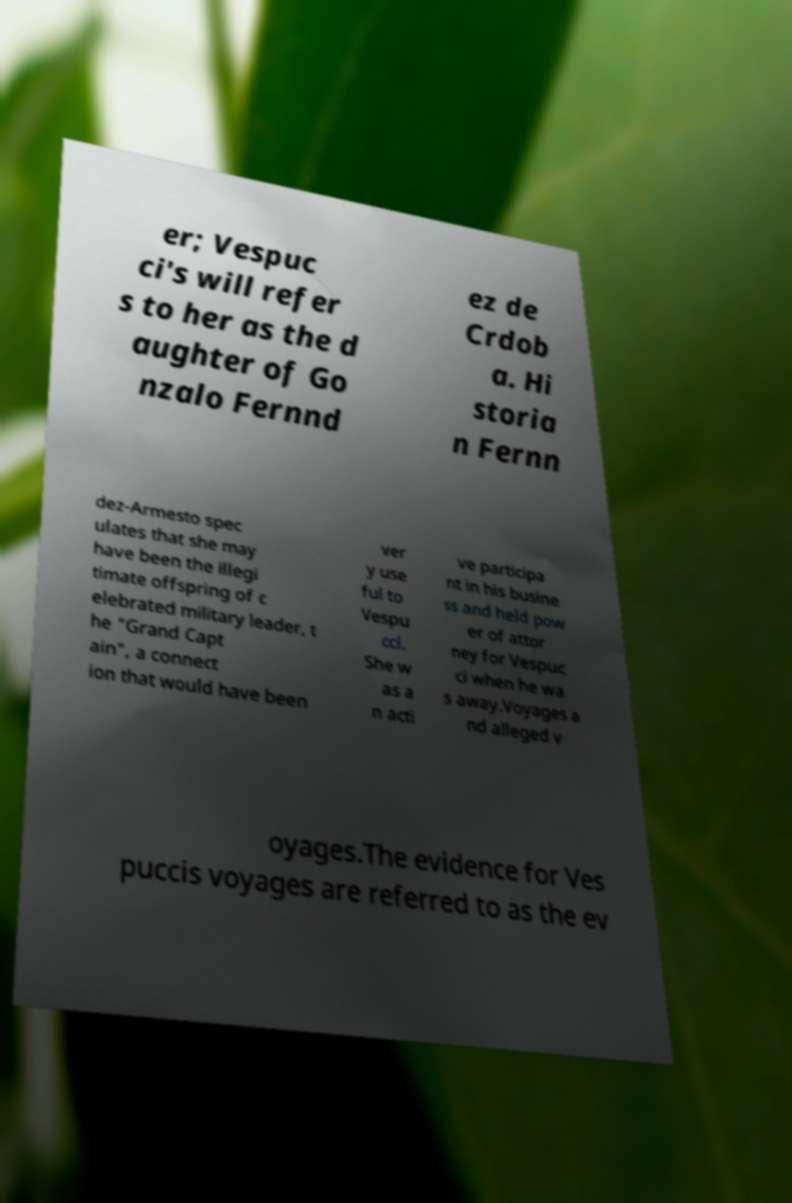Please identify and transcribe the text found in this image. er; Vespuc ci's will refer s to her as the d aughter of Go nzalo Fernnd ez de Crdob a. Hi storia n Fernn dez-Armesto spec ulates that she may have been the illegi timate offspring of c elebrated military leader, t he "Grand Capt ain", a connect ion that would have been ver y use ful to Vespu cci. She w as a n acti ve participa nt in his busine ss and held pow er of attor ney for Vespuc ci when he wa s away.Voyages a nd alleged v oyages.The evidence for Ves puccis voyages are referred to as the ev 